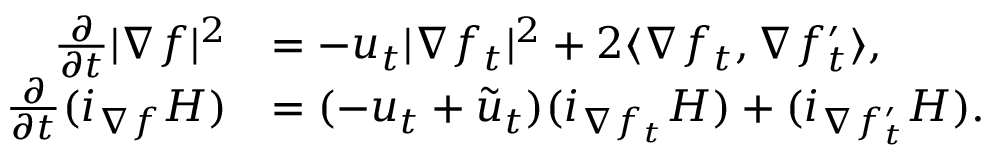<formula> <loc_0><loc_0><loc_500><loc_500>\begin{array} { r l } { \frac { \partial } { \partial t } | \nabla f | ^ { 2 } } & { = - u _ { t } | \nabla f _ { t } | ^ { 2 } + 2 \langle \nabla f _ { t } , \nabla f _ { t } ^ { \prime } \rangle , } \\ { \frac { \partial } { \partial t } ( i _ { \nabla f } H ) } & { = ( - u _ { t } + \tilde { u } _ { t } ) ( i _ { \nabla { f _ { t } } } H ) + ( i _ { \nabla { f _ { t } ^ { \prime } } } H ) . } \end{array}</formula> 